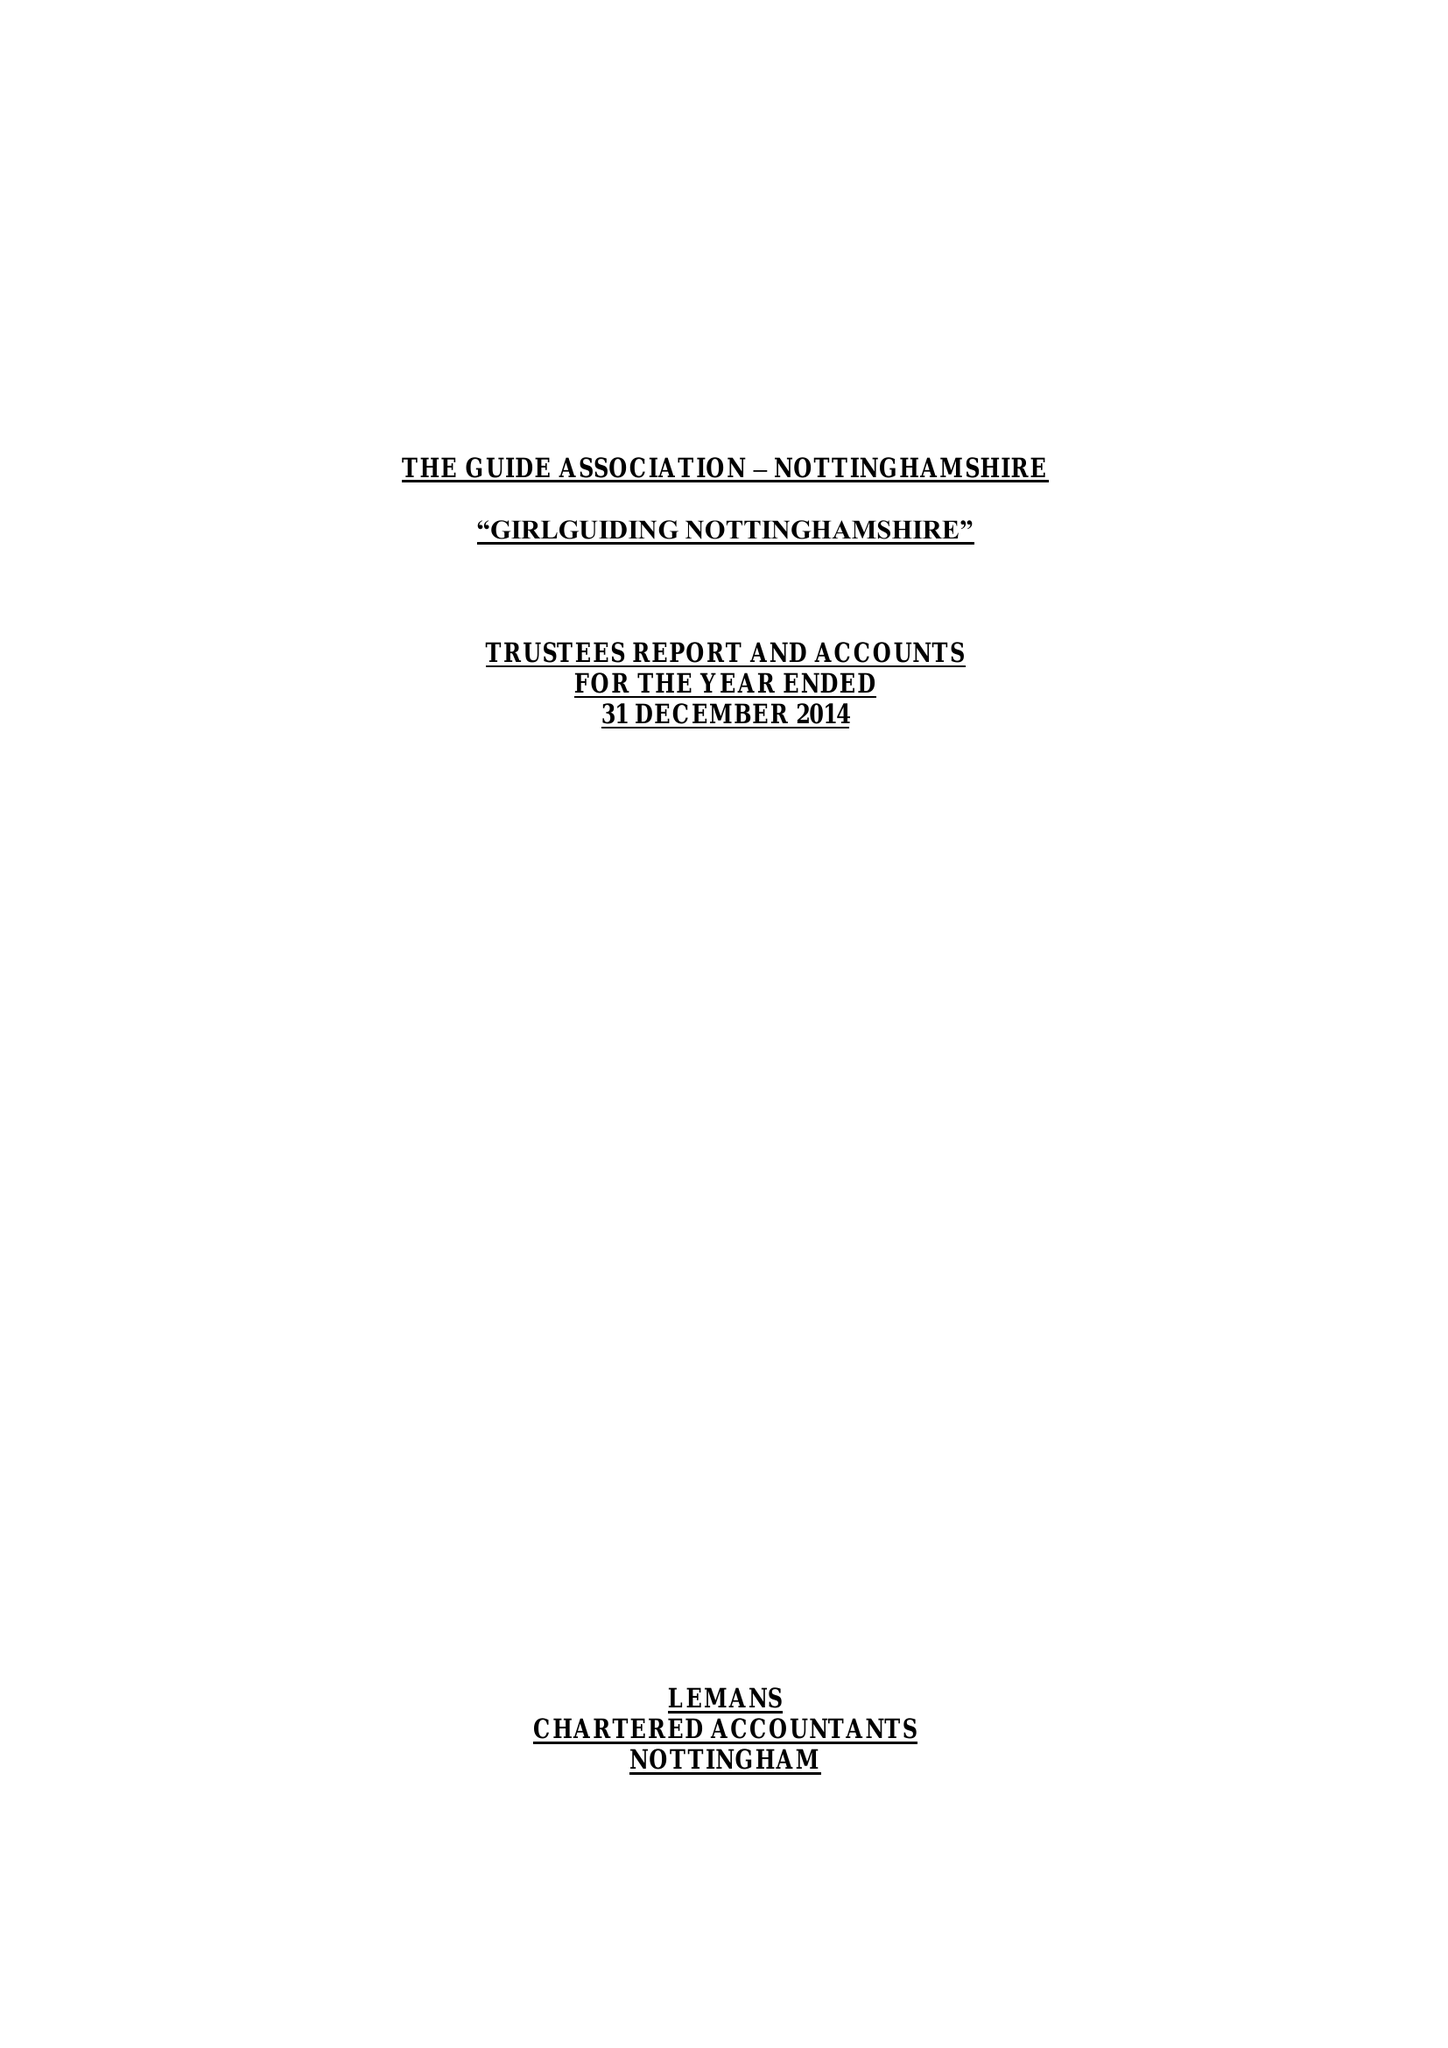What is the value for the charity_name?
Answer the question using a single word or phrase. The Guide Association - Nottinghamshire County 